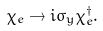Convert formula to latex. <formula><loc_0><loc_0><loc_500><loc_500>\chi _ { e } \rightarrow i \sigma _ { y } \chi ^ { \dagger } _ { e } .</formula> 